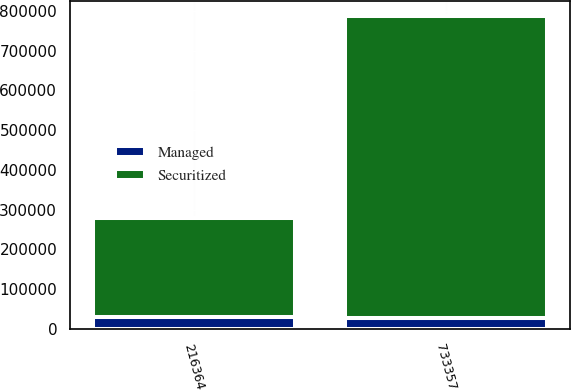Convert chart to OTSL. <chart><loc_0><loc_0><loc_500><loc_500><stacked_bar_chart><ecel><fcel>216364<fcel>733357<nl><fcel>Managed<fcel>30722<fcel>26519<nl><fcel>Securitized<fcel>247086<fcel>759876<nl></chart> 